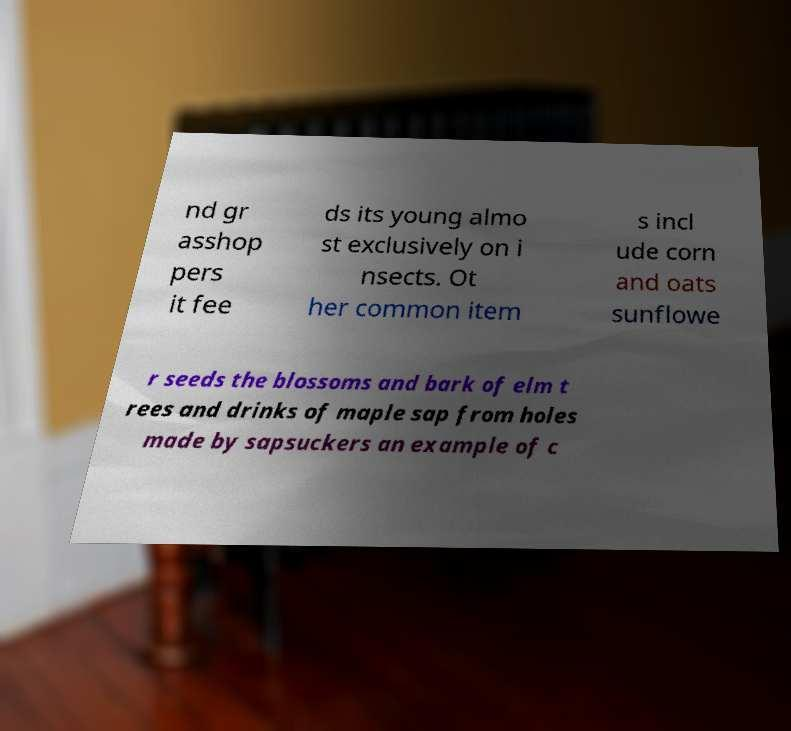I need the written content from this picture converted into text. Can you do that? nd gr asshop pers it fee ds its young almo st exclusively on i nsects. Ot her common item s incl ude corn and oats sunflowe r seeds the blossoms and bark of elm t rees and drinks of maple sap from holes made by sapsuckers an example of c 